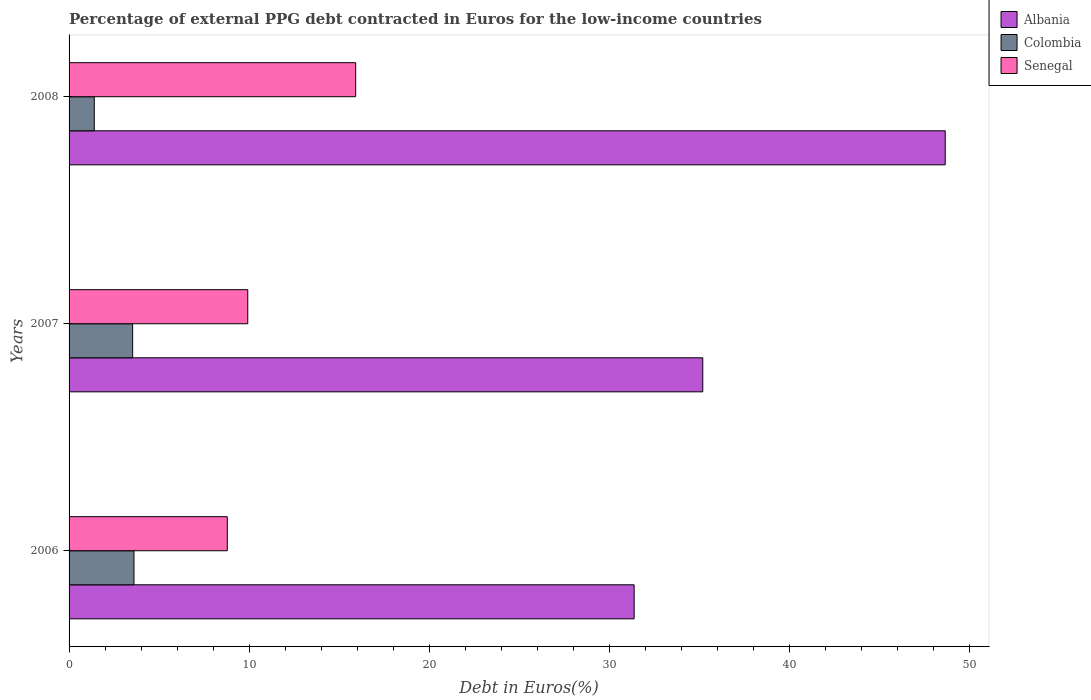How many different coloured bars are there?
Ensure brevity in your answer.  3. How many groups of bars are there?
Keep it short and to the point. 3. Are the number of bars per tick equal to the number of legend labels?
Your answer should be compact. Yes. Are the number of bars on each tick of the Y-axis equal?
Provide a short and direct response. Yes. What is the label of the 2nd group of bars from the top?
Provide a short and direct response. 2007. In how many cases, is the number of bars for a given year not equal to the number of legend labels?
Your answer should be compact. 0. What is the percentage of external PPG debt contracted in Euros in Albania in 2007?
Make the answer very short. 35.18. Across all years, what is the maximum percentage of external PPG debt contracted in Euros in Senegal?
Give a very brief answer. 15.91. Across all years, what is the minimum percentage of external PPG debt contracted in Euros in Albania?
Keep it short and to the point. 31.37. In which year was the percentage of external PPG debt contracted in Euros in Albania maximum?
Keep it short and to the point. 2008. What is the total percentage of external PPG debt contracted in Euros in Colombia in the graph?
Keep it short and to the point. 8.53. What is the difference between the percentage of external PPG debt contracted in Euros in Senegal in 2006 and that in 2007?
Give a very brief answer. -1.14. What is the difference between the percentage of external PPG debt contracted in Euros in Colombia in 2006 and the percentage of external PPG debt contracted in Euros in Senegal in 2007?
Your answer should be very brief. -6.32. What is the average percentage of external PPG debt contracted in Euros in Colombia per year?
Offer a terse response. 2.84. In the year 2007, what is the difference between the percentage of external PPG debt contracted in Euros in Albania and percentage of external PPG debt contracted in Euros in Senegal?
Provide a succinct answer. 25.26. In how many years, is the percentage of external PPG debt contracted in Euros in Albania greater than 22 %?
Make the answer very short. 3. What is the ratio of the percentage of external PPG debt contracted in Euros in Senegal in 2006 to that in 2007?
Keep it short and to the point. 0.89. Is the percentage of external PPG debt contracted in Euros in Senegal in 2006 less than that in 2008?
Your answer should be very brief. Yes. What is the difference between the highest and the second highest percentage of external PPG debt contracted in Euros in Albania?
Make the answer very short. 13.46. What is the difference between the highest and the lowest percentage of external PPG debt contracted in Euros in Senegal?
Your response must be concise. 7.13. What does the 3rd bar from the top in 2006 represents?
Offer a very short reply. Albania. What does the 3rd bar from the bottom in 2007 represents?
Give a very brief answer. Senegal. Is it the case that in every year, the sum of the percentage of external PPG debt contracted in Euros in Senegal and percentage of external PPG debt contracted in Euros in Albania is greater than the percentage of external PPG debt contracted in Euros in Colombia?
Provide a short and direct response. Yes. How many bars are there?
Give a very brief answer. 9. Are all the bars in the graph horizontal?
Your answer should be compact. Yes. What is the difference between two consecutive major ticks on the X-axis?
Provide a short and direct response. 10. Are the values on the major ticks of X-axis written in scientific E-notation?
Your answer should be very brief. No. Does the graph contain grids?
Your response must be concise. No. What is the title of the graph?
Your answer should be compact. Percentage of external PPG debt contracted in Euros for the low-income countries. Does "Tuvalu" appear as one of the legend labels in the graph?
Make the answer very short. No. What is the label or title of the X-axis?
Keep it short and to the point. Debt in Euros(%). What is the label or title of the Y-axis?
Your response must be concise. Years. What is the Debt in Euros(%) of Albania in 2006?
Keep it short and to the point. 31.37. What is the Debt in Euros(%) in Colombia in 2006?
Your response must be concise. 3.6. What is the Debt in Euros(%) of Senegal in 2006?
Ensure brevity in your answer.  8.78. What is the Debt in Euros(%) of Albania in 2007?
Make the answer very short. 35.18. What is the Debt in Euros(%) in Colombia in 2007?
Offer a very short reply. 3.53. What is the Debt in Euros(%) of Senegal in 2007?
Make the answer very short. 9.92. What is the Debt in Euros(%) of Albania in 2008?
Give a very brief answer. 48.64. What is the Debt in Euros(%) of Colombia in 2008?
Provide a succinct answer. 1.4. What is the Debt in Euros(%) in Senegal in 2008?
Give a very brief answer. 15.91. Across all years, what is the maximum Debt in Euros(%) of Albania?
Ensure brevity in your answer.  48.64. Across all years, what is the maximum Debt in Euros(%) in Colombia?
Your response must be concise. 3.6. Across all years, what is the maximum Debt in Euros(%) in Senegal?
Your answer should be very brief. 15.91. Across all years, what is the minimum Debt in Euros(%) of Albania?
Ensure brevity in your answer.  31.37. Across all years, what is the minimum Debt in Euros(%) of Colombia?
Give a very brief answer. 1.4. Across all years, what is the minimum Debt in Euros(%) of Senegal?
Your response must be concise. 8.78. What is the total Debt in Euros(%) of Albania in the graph?
Provide a short and direct response. 115.19. What is the total Debt in Euros(%) of Colombia in the graph?
Your answer should be compact. 8.53. What is the total Debt in Euros(%) in Senegal in the graph?
Give a very brief answer. 34.61. What is the difference between the Debt in Euros(%) in Albania in 2006 and that in 2007?
Your answer should be compact. -3.81. What is the difference between the Debt in Euros(%) in Colombia in 2006 and that in 2007?
Your answer should be very brief. 0.07. What is the difference between the Debt in Euros(%) in Senegal in 2006 and that in 2007?
Offer a very short reply. -1.14. What is the difference between the Debt in Euros(%) in Albania in 2006 and that in 2008?
Keep it short and to the point. -17.27. What is the difference between the Debt in Euros(%) in Colombia in 2006 and that in 2008?
Provide a short and direct response. 2.2. What is the difference between the Debt in Euros(%) in Senegal in 2006 and that in 2008?
Your answer should be compact. -7.13. What is the difference between the Debt in Euros(%) of Albania in 2007 and that in 2008?
Keep it short and to the point. -13.46. What is the difference between the Debt in Euros(%) in Colombia in 2007 and that in 2008?
Keep it short and to the point. 2.13. What is the difference between the Debt in Euros(%) in Senegal in 2007 and that in 2008?
Make the answer very short. -5.99. What is the difference between the Debt in Euros(%) in Albania in 2006 and the Debt in Euros(%) in Colombia in 2007?
Give a very brief answer. 27.84. What is the difference between the Debt in Euros(%) in Albania in 2006 and the Debt in Euros(%) in Senegal in 2007?
Provide a succinct answer. 21.45. What is the difference between the Debt in Euros(%) of Colombia in 2006 and the Debt in Euros(%) of Senegal in 2007?
Provide a short and direct response. -6.32. What is the difference between the Debt in Euros(%) of Albania in 2006 and the Debt in Euros(%) of Colombia in 2008?
Provide a short and direct response. 29.97. What is the difference between the Debt in Euros(%) of Albania in 2006 and the Debt in Euros(%) of Senegal in 2008?
Offer a terse response. 15.46. What is the difference between the Debt in Euros(%) in Colombia in 2006 and the Debt in Euros(%) in Senegal in 2008?
Ensure brevity in your answer.  -12.31. What is the difference between the Debt in Euros(%) of Albania in 2007 and the Debt in Euros(%) of Colombia in 2008?
Ensure brevity in your answer.  33.78. What is the difference between the Debt in Euros(%) of Albania in 2007 and the Debt in Euros(%) of Senegal in 2008?
Give a very brief answer. 19.27. What is the difference between the Debt in Euros(%) in Colombia in 2007 and the Debt in Euros(%) in Senegal in 2008?
Your answer should be very brief. -12.38. What is the average Debt in Euros(%) of Albania per year?
Keep it short and to the point. 38.4. What is the average Debt in Euros(%) of Colombia per year?
Your response must be concise. 2.84. What is the average Debt in Euros(%) in Senegal per year?
Offer a terse response. 11.54. In the year 2006, what is the difference between the Debt in Euros(%) in Albania and Debt in Euros(%) in Colombia?
Your response must be concise. 27.77. In the year 2006, what is the difference between the Debt in Euros(%) in Albania and Debt in Euros(%) in Senegal?
Offer a terse response. 22.59. In the year 2006, what is the difference between the Debt in Euros(%) in Colombia and Debt in Euros(%) in Senegal?
Provide a succinct answer. -5.18. In the year 2007, what is the difference between the Debt in Euros(%) of Albania and Debt in Euros(%) of Colombia?
Give a very brief answer. 31.65. In the year 2007, what is the difference between the Debt in Euros(%) in Albania and Debt in Euros(%) in Senegal?
Provide a short and direct response. 25.26. In the year 2007, what is the difference between the Debt in Euros(%) of Colombia and Debt in Euros(%) of Senegal?
Your answer should be compact. -6.39. In the year 2008, what is the difference between the Debt in Euros(%) in Albania and Debt in Euros(%) in Colombia?
Give a very brief answer. 47.24. In the year 2008, what is the difference between the Debt in Euros(%) of Albania and Debt in Euros(%) of Senegal?
Provide a short and direct response. 32.73. In the year 2008, what is the difference between the Debt in Euros(%) of Colombia and Debt in Euros(%) of Senegal?
Ensure brevity in your answer.  -14.51. What is the ratio of the Debt in Euros(%) in Albania in 2006 to that in 2007?
Provide a succinct answer. 0.89. What is the ratio of the Debt in Euros(%) of Colombia in 2006 to that in 2007?
Keep it short and to the point. 1.02. What is the ratio of the Debt in Euros(%) in Senegal in 2006 to that in 2007?
Keep it short and to the point. 0.89. What is the ratio of the Debt in Euros(%) in Albania in 2006 to that in 2008?
Offer a very short reply. 0.64. What is the ratio of the Debt in Euros(%) of Colombia in 2006 to that in 2008?
Offer a terse response. 2.58. What is the ratio of the Debt in Euros(%) of Senegal in 2006 to that in 2008?
Your response must be concise. 0.55. What is the ratio of the Debt in Euros(%) of Albania in 2007 to that in 2008?
Ensure brevity in your answer.  0.72. What is the ratio of the Debt in Euros(%) of Colombia in 2007 to that in 2008?
Make the answer very short. 2.52. What is the ratio of the Debt in Euros(%) of Senegal in 2007 to that in 2008?
Your answer should be very brief. 0.62. What is the difference between the highest and the second highest Debt in Euros(%) in Albania?
Provide a succinct answer. 13.46. What is the difference between the highest and the second highest Debt in Euros(%) of Colombia?
Your response must be concise. 0.07. What is the difference between the highest and the second highest Debt in Euros(%) in Senegal?
Provide a short and direct response. 5.99. What is the difference between the highest and the lowest Debt in Euros(%) in Albania?
Provide a succinct answer. 17.27. What is the difference between the highest and the lowest Debt in Euros(%) of Colombia?
Provide a succinct answer. 2.2. What is the difference between the highest and the lowest Debt in Euros(%) in Senegal?
Keep it short and to the point. 7.13. 